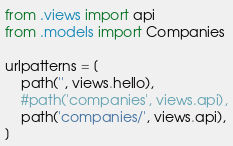Convert code to text. <code><loc_0><loc_0><loc_500><loc_500><_Python_>from .views import api
from .models import Companies

urlpatterns = [
	path('', views.hello),
	#path('companies', views.api),
	path('companies/', views.api),
]
</code> 